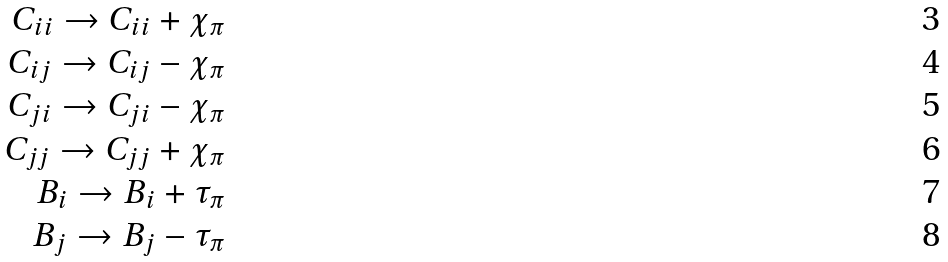Convert formula to latex. <formula><loc_0><loc_0><loc_500><loc_500>C _ { i i } \to C _ { i i } + \chi _ { \pi } \\ C _ { i j } \to C _ { i j } - \chi _ { \pi } \\ C _ { j i } \to C _ { j i } - \chi _ { \pi } \\ C _ { j j } \to C _ { j j } + \chi _ { \pi } \\ B _ { i } \to B _ { i } + \tau _ { \pi } \\ B _ { j } \to B _ { j } - \tau _ { \pi }</formula> 